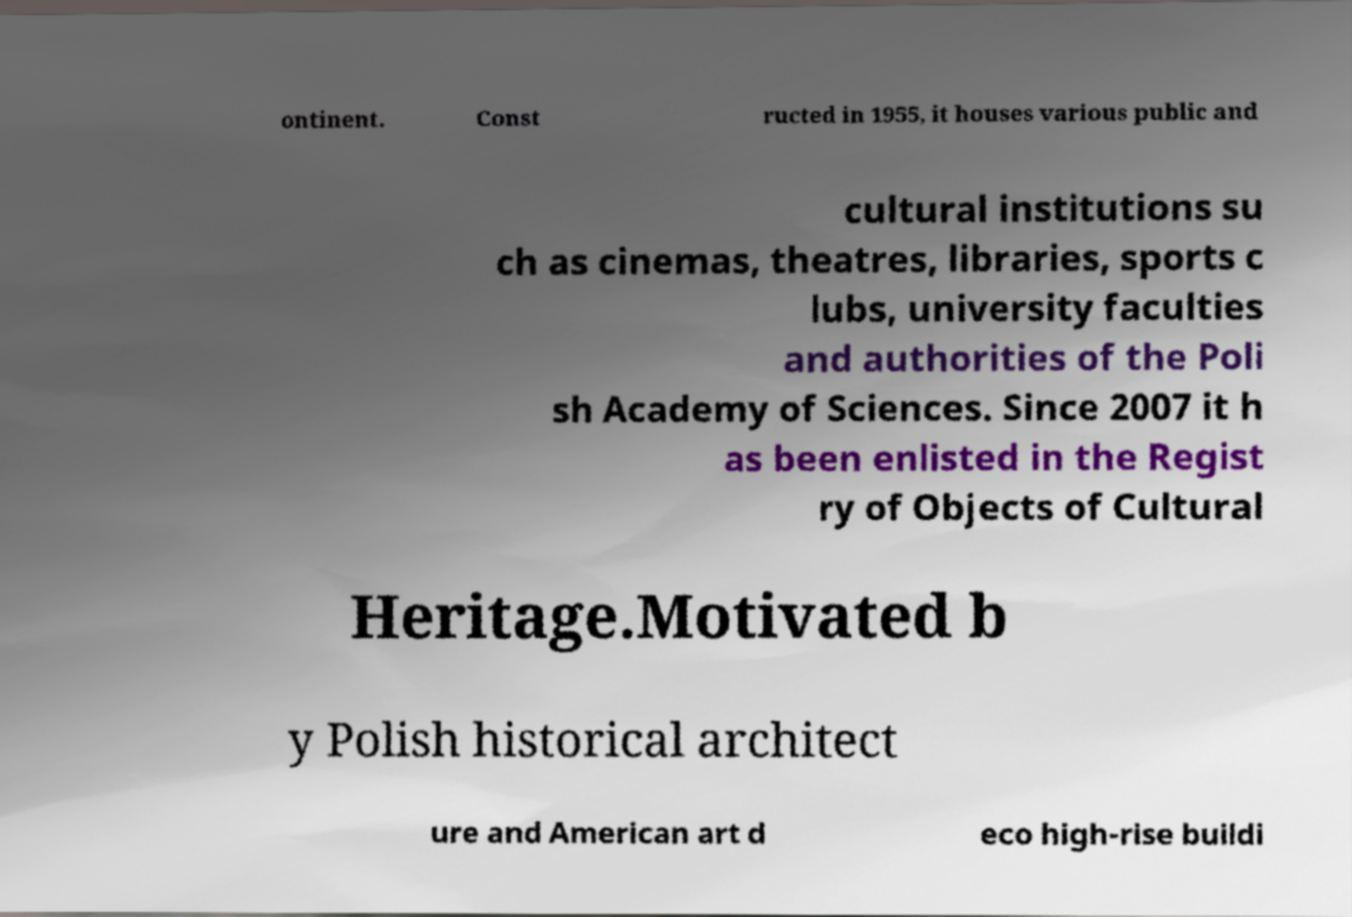Please read and relay the text visible in this image. What does it say? ontinent. Const ructed in 1955, it houses various public and cultural institutions su ch as cinemas, theatres, libraries, sports c lubs, university faculties and authorities of the Poli sh Academy of Sciences. Since 2007 it h as been enlisted in the Regist ry of Objects of Cultural Heritage.Motivated b y Polish historical architect ure and American art d eco high-rise buildi 